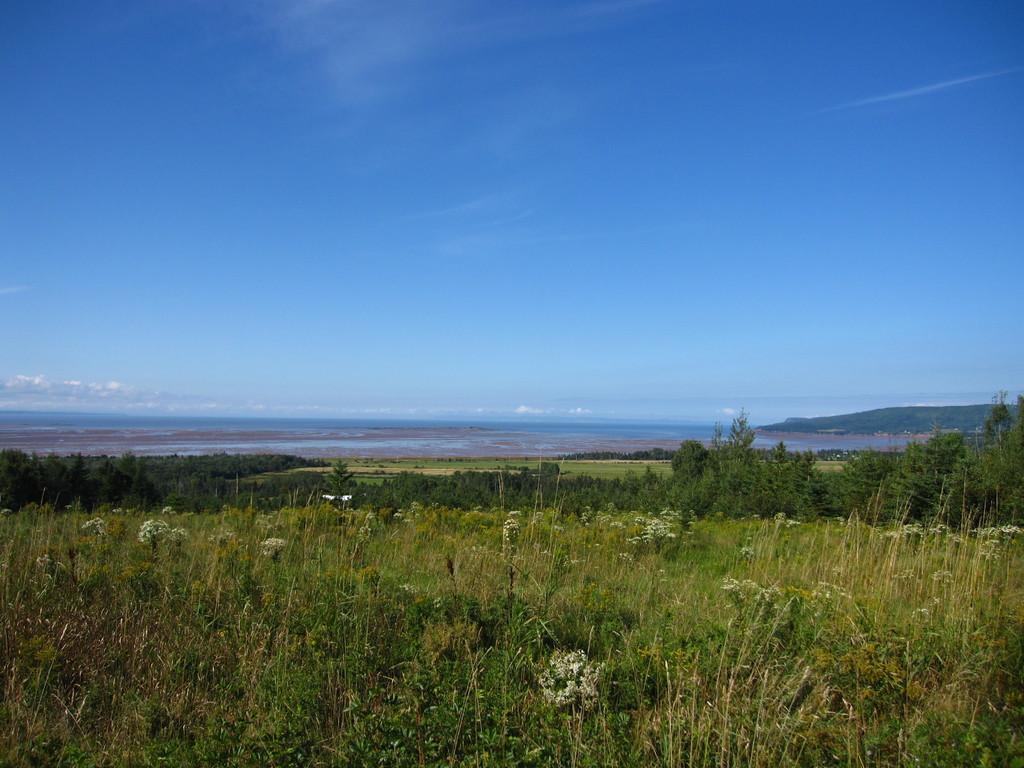Describe this image in one or two sentences. The image is clicked in a field. In the foreground of the image there are plants and flowers. In the center of the image there are trees and field. In the background there are hill and water. Sky is clear and it is sunny. 